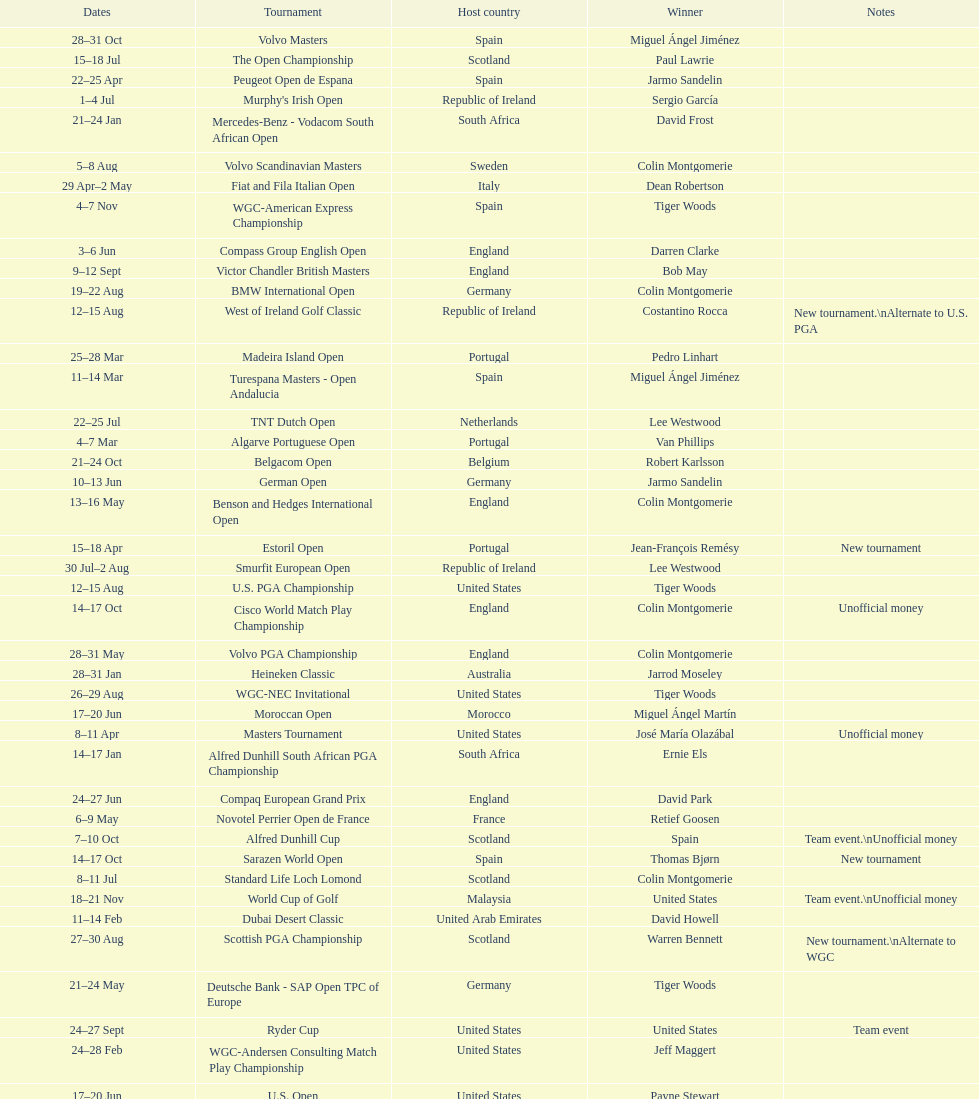How many consecutive times was south africa the host country? 2. 